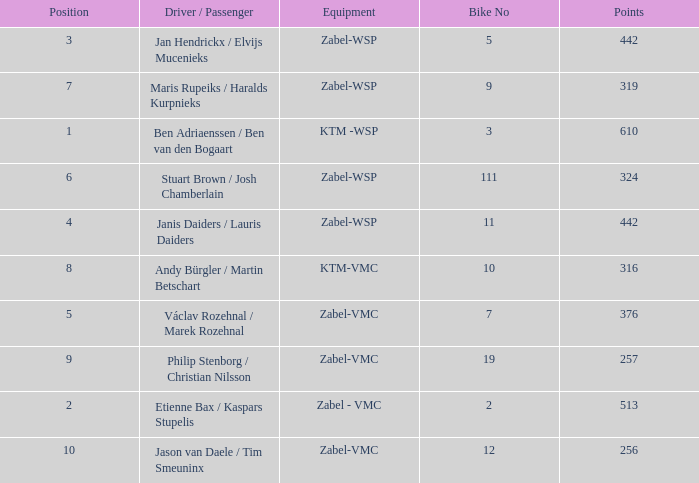What is the Equipment that has a Point bigger than 256, and a Position of 3? Zabel-WSP. 